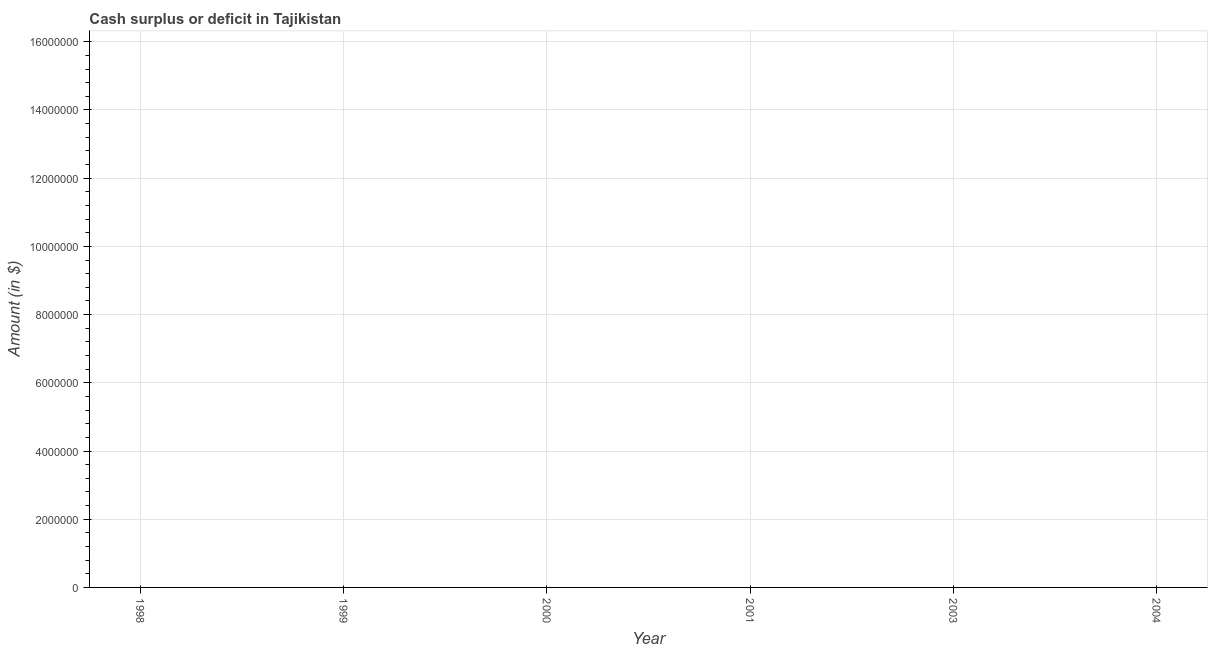What is the cash surplus or deficit in 2003?
Offer a very short reply. 0. What is the average cash surplus or deficit per year?
Give a very brief answer. 0. What is the median cash surplus or deficit?
Your answer should be compact. 0. What is the title of the graph?
Ensure brevity in your answer.  Cash surplus or deficit in Tajikistan. What is the label or title of the Y-axis?
Keep it short and to the point. Amount (in $). What is the Amount (in $) in 1999?
Offer a very short reply. 0. What is the Amount (in $) in 2001?
Keep it short and to the point. 0. What is the Amount (in $) in 2003?
Provide a short and direct response. 0. What is the Amount (in $) in 2004?
Your answer should be very brief. 0. 